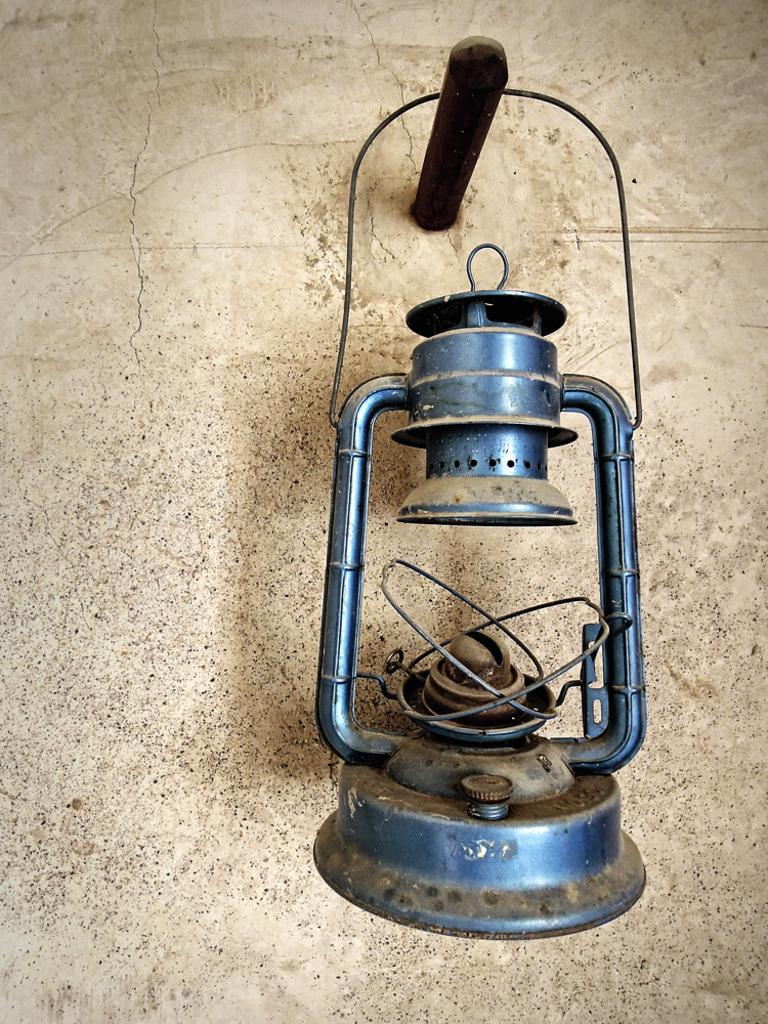What object can be seen in the image? There is a lantern in the image. Where is the lantern located? The lantern is hanged on a wall. How much money is hidden inside the lantern in the image? There is no indication of money or any hidden compartments in the lantern in the image. 